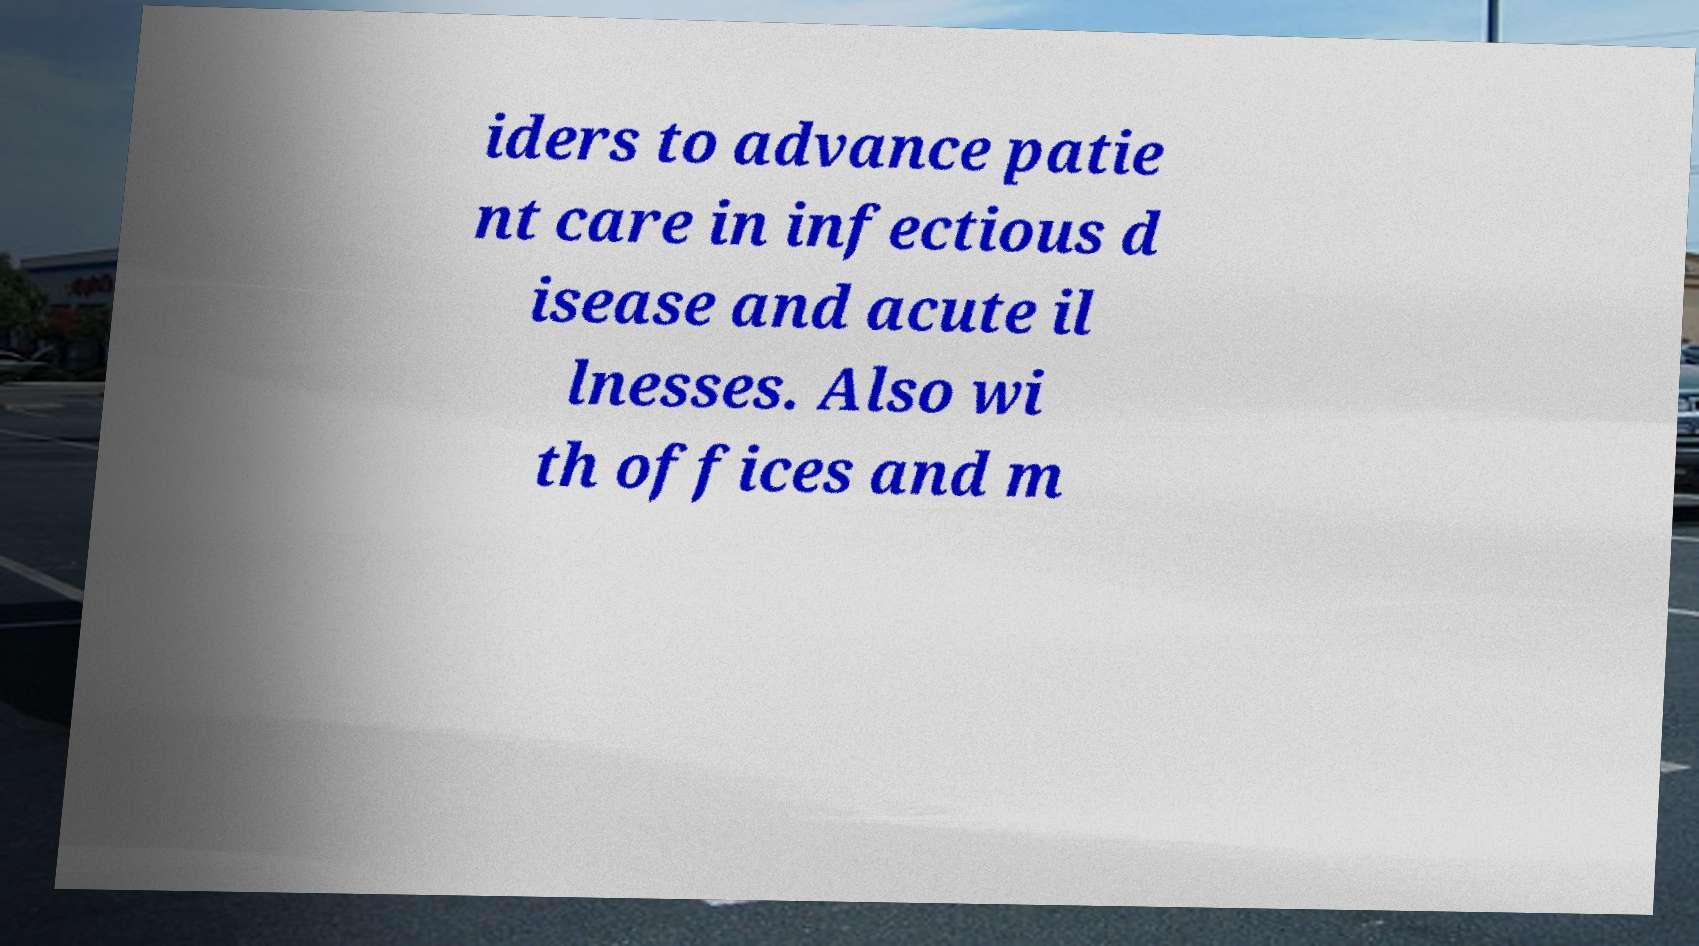I need the written content from this picture converted into text. Can you do that? iders to advance patie nt care in infectious d isease and acute il lnesses. Also wi th offices and m 